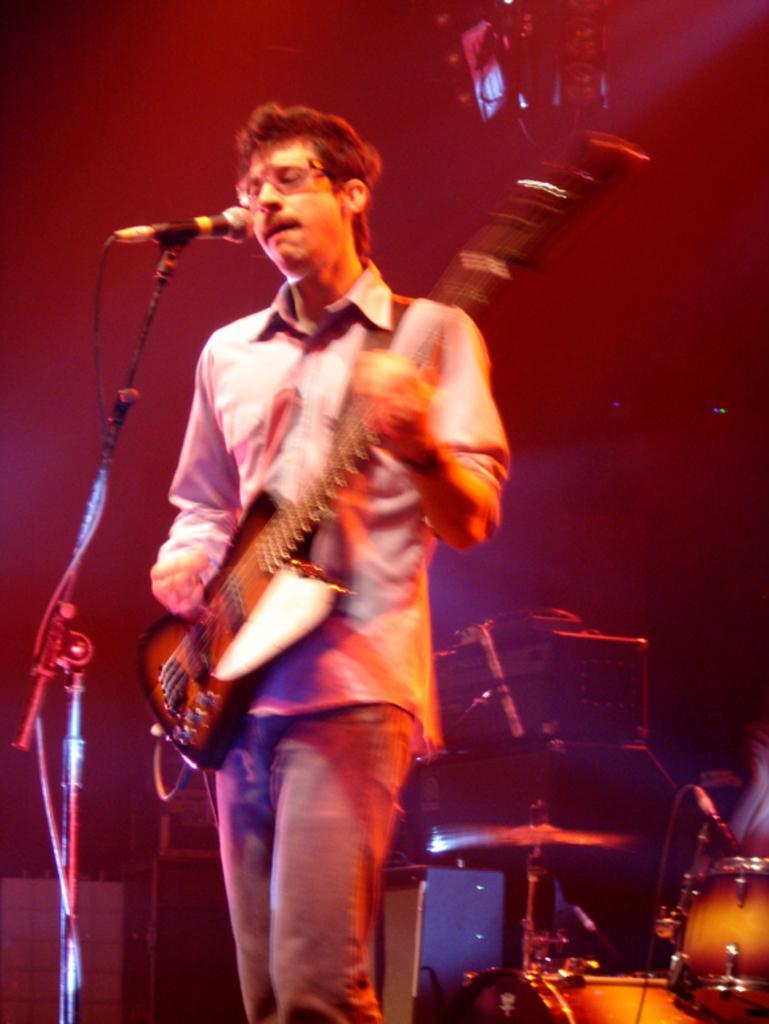How would you summarize this image in a sentence or two? In this image I can see a man is standing and I can see he is holding a guitar. Here I can see a mic and in the background I can see drum set. I can also see this image is little bit blurry. 